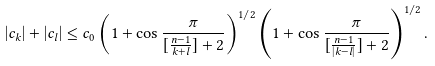Convert formula to latex. <formula><loc_0><loc_0><loc_500><loc_500>\left | c _ { k } \right | + \left | c _ { l } \right | \leq c _ { 0 } \left ( 1 + \cos \frac { \pi } { [ \frac { n - 1 } { k + l } ] + 2 } \right ) ^ { 1 / 2 } \left ( 1 + \cos \frac { \pi } { [ \frac { n - 1 } { \left | k - l \right | } ] + 2 } \right ) ^ { 1 / 2 } .</formula> 